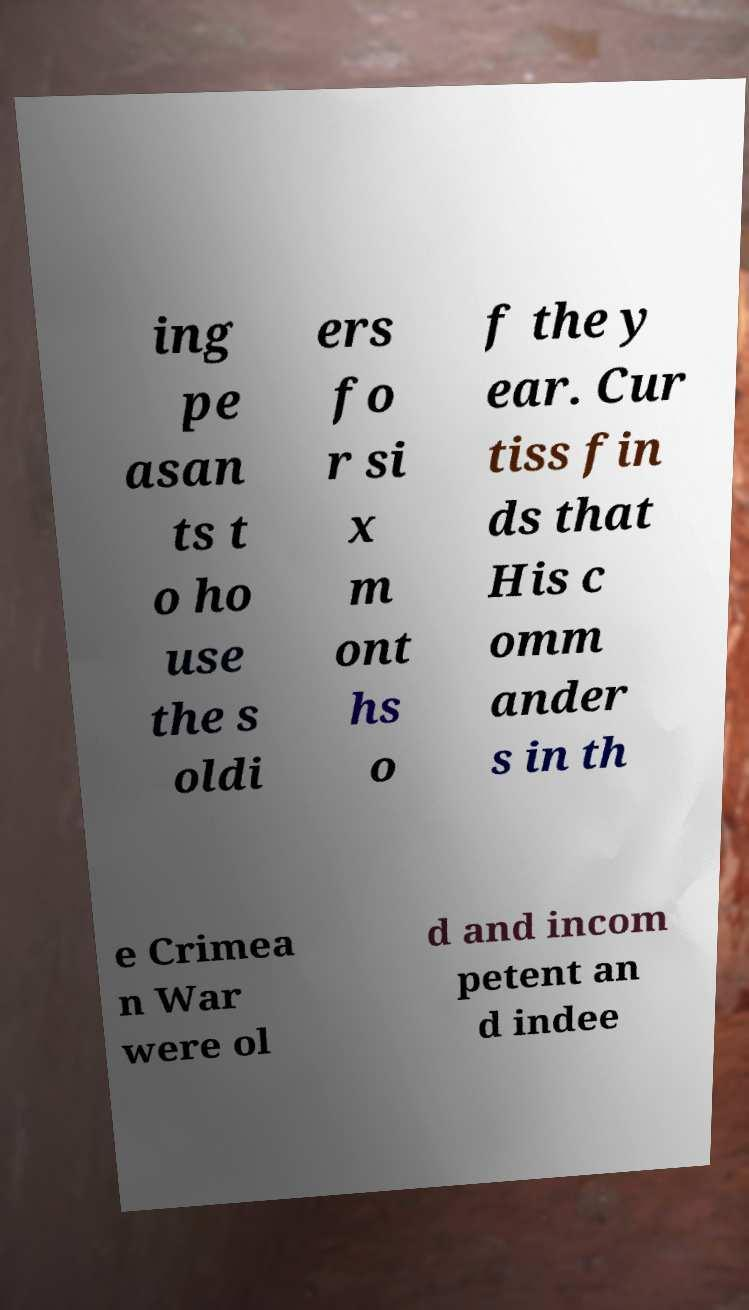Can you accurately transcribe the text from the provided image for me? ing pe asan ts t o ho use the s oldi ers fo r si x m ont hs o f the y ear. Cur tiss fin ds that His c omm ander s in th e Crimea n War were ol d and incom petent an d indee 